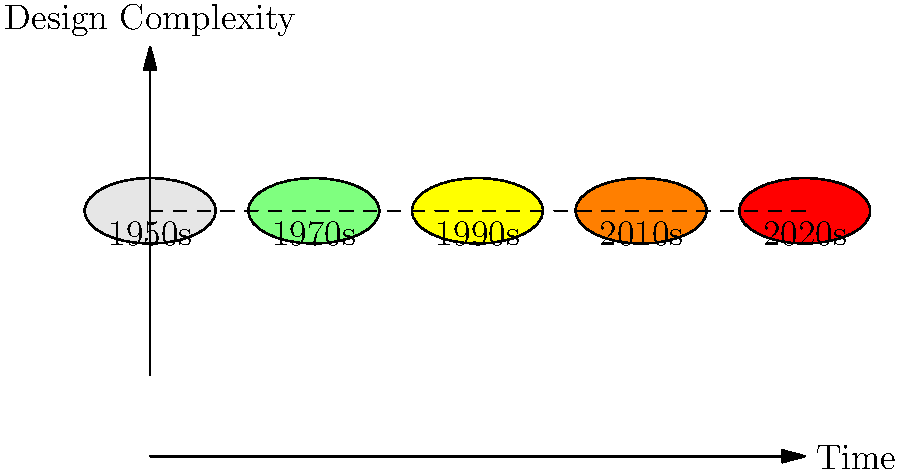Based on the graph showing the evolution of soccer cleats over time, which decade marked a significant increase in design complexity, likely corresponding to advancements in materials and technology? To answer this question, we need to analyze the graph step-by-step:

1. The x-axis represents time, starting from the 1950s and progressing to the 2020s.
2. The y-axis represents design complexity, with higher positions indicating more complex designs.
3. Each cleat is represented by a colored oval, with the color changing from light grey to red as time progresses.
4. The vertical position of each cleat indicates its relative design complexity.

Observing the graph:
1. 1950s cleats (light grey) are at the baseline, indicating basic designs.
2. 1970s cleats (light green) show a slight increase in complexity.
3. 1990s cleats (yellow) demonstrate a noticeable jump in design complexity.
4. 2010s cleats (orange) continue the trend of increasing complexity.
5. 2020s cleats (red) show the highest level of design complexity.

The most significant increase in design complexity occurs between the 1970s and 1990s, as evidenced by the larger vertical jump between these two decades compared to others.

This increase likely corresponds to advancements in materials and technology during this period, which allowed for more sophisticated cleat designs.
Answer: 1990s 